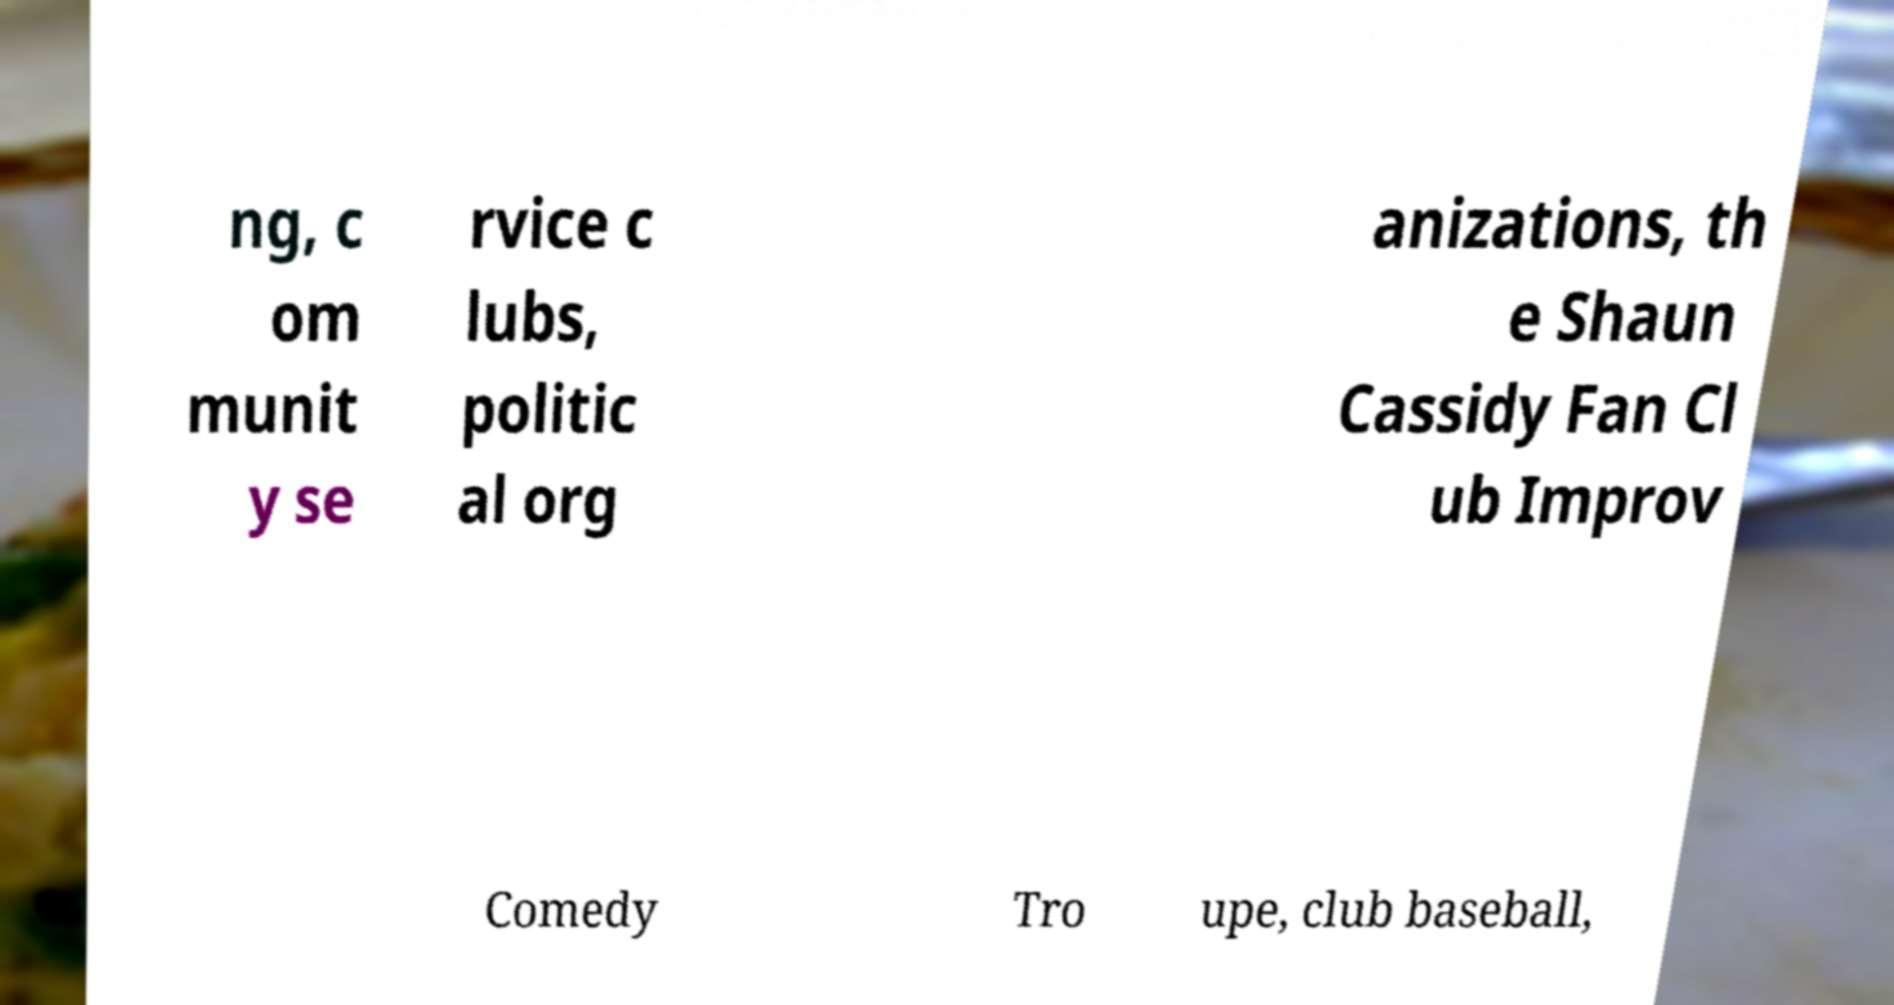What messages or text are displayed in this image? I need them in a readable, typed format. ng, c om munit y se rvice c lubs, politic al org anizations, th e Shaun Cassidy Fan Cl ub Improv Comedy Tro upe, club baseball, 